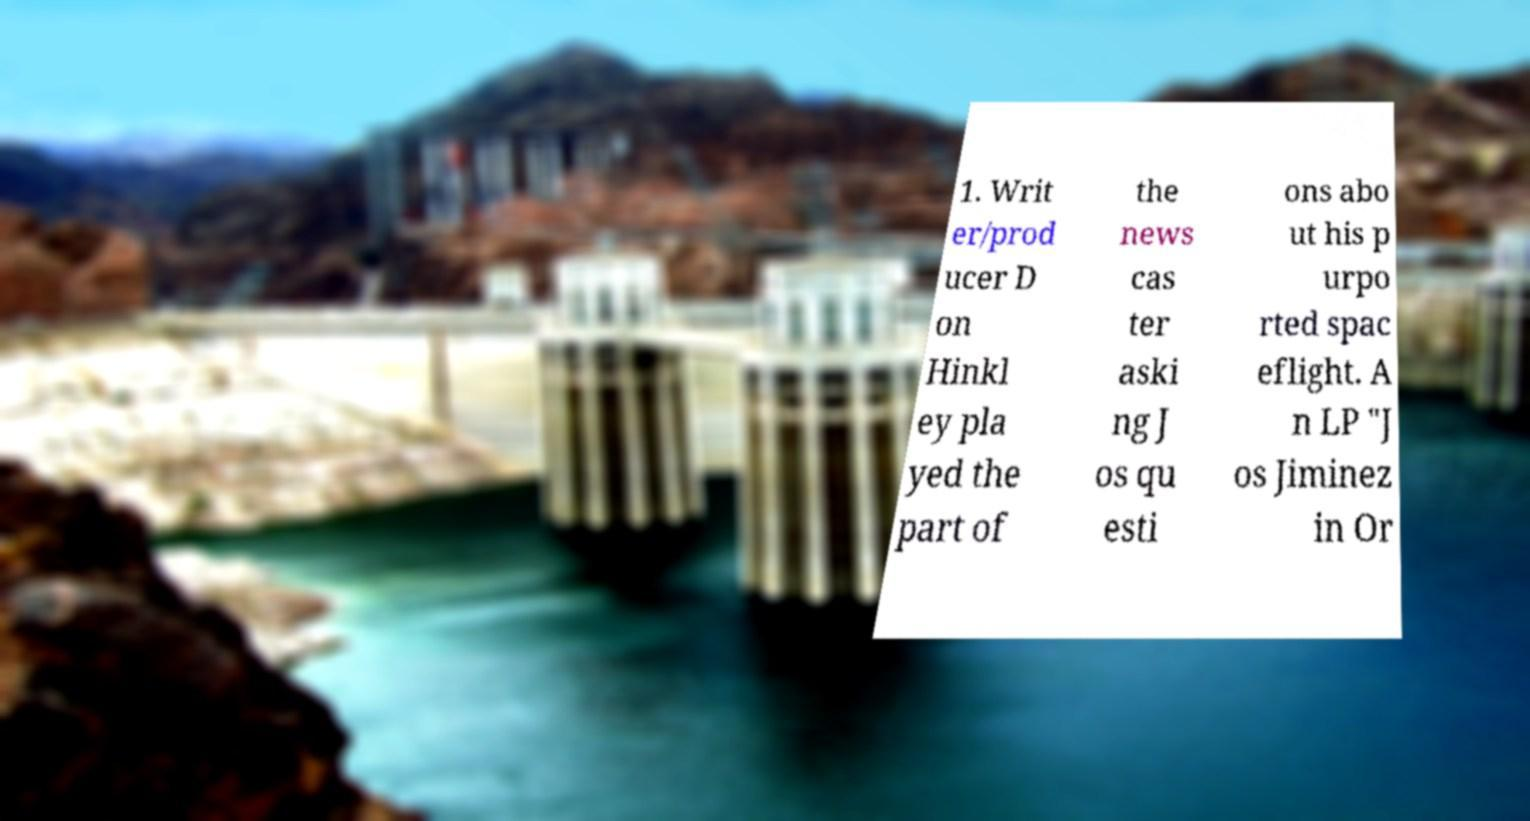There's text embedded in this image that I need extracted. Can you transcribe it verbatim? 1. Writ er/prod ucer D on Hinkl ey pla yed the part of the news cas ter aski ng J os qu esti ons abo ut his p urpo rted spac eflight. A n LP "J os Jiminez in Or 